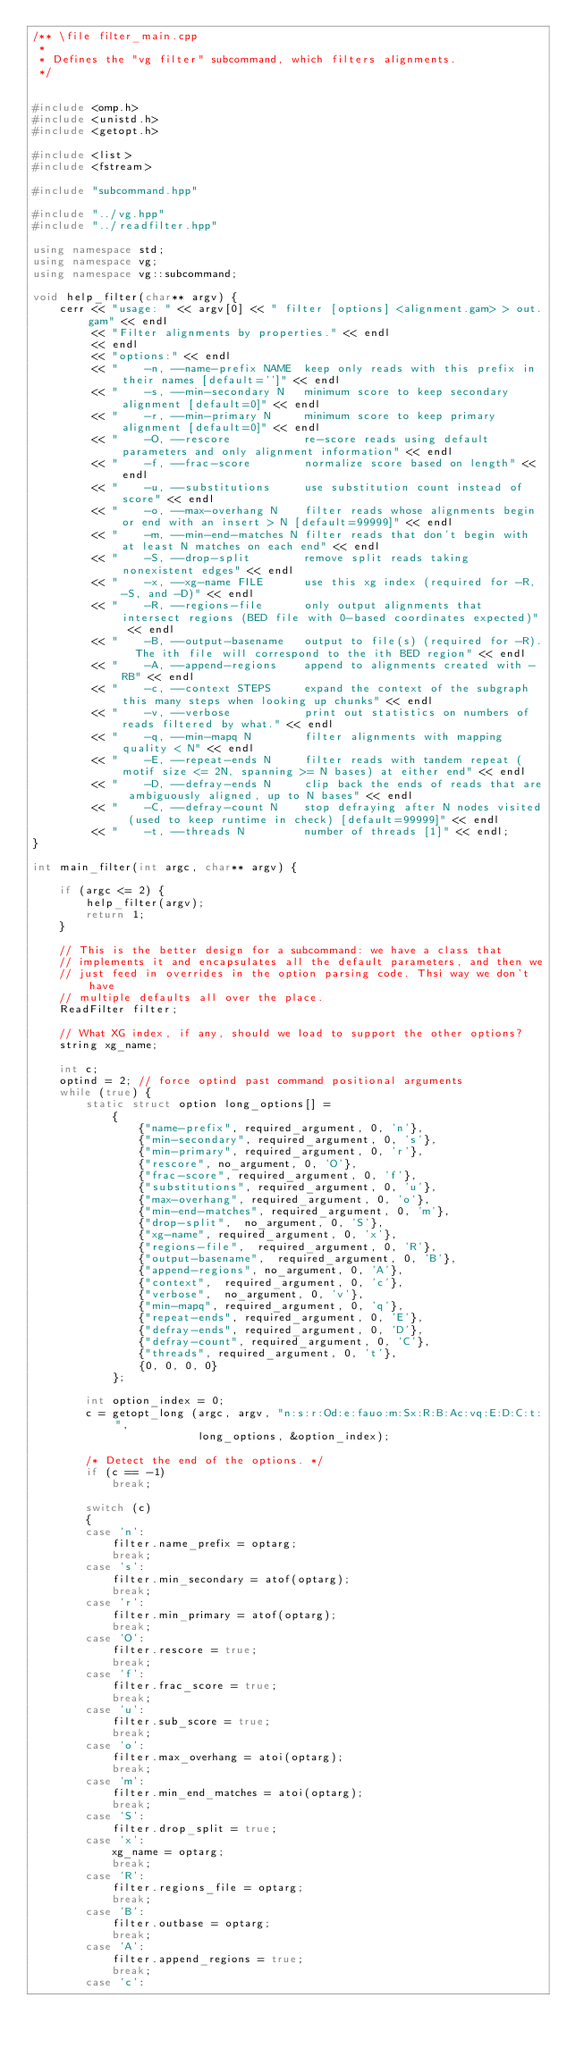Convert code to text. <code><loc_0><loc_0><loc_500><loc_500><_C++_>/** \file filter_main.cpp
 *
 * Defines the "vg filter" subcommand, which filters alignments.
 */


#include <omp.h>
#include <unistd.h>
#include <getopt.h>

#include <list>
#include <fstream>

#include "subcommand.hpp"

#include "../vg.hpp"
#include "../readfilter.hpp"

using namespace std;
using namespace vg;
using namespace vg::subcommand;

void help_filter(char** argv) {
    cerr << "usage: " << argv[0] << " filter [options] <alignment.gam> > out.gam" << endl
         << "Filter alignments by properties." << endl
         << endl
         << "options:" << endl
         << "    -n, --name-prefix NAME  keep only reads with this prefix in their names [default='']" << endl
         << "    -s, --min-secondary N   minimum score to keep secondary alignment [default=0]" << endl
         << "    -r, --min-primary N     minimum score to keep primary alignment [default=0]" << endl
         << "    -O, --rescore           re-score reads using default parameters and only alignment information" << endl
         << "    -f, --frac-score        normalize score based on length" << endl
         << "    -u, --substitutions     use substitution count instead of score" << endl
         << "    -o, --max-overhang N    filter reads whose alignments begin or end with an insert > N [default=99999]" << endl
         << "    -m, --min-end-matches N filter reads that don't begin with at least N matches on each end" << endl
         << "    -S, --drop-split        remove split reads taking nonexistent edges" << endl
         << "    -x, --xg-name FILE      use this xg index (required for -R, -S, and -D)" << endl
         << "    -R, --regions-file      only output alignments that intersect regions (BED file with 0-based coordinates expected)" << endl
         << "    -B, --output-basename   output to file(s) (required for -R).  The ith file will correspond to the ith BED region" << endl
         << "    -A, --append-regions    append to alignments created with -RB" << endl
         << "    -c, --context STEPS     expand the context of the subgraph this many steps when looking up chunks" << endl
         << "    -v, --verbose           print out statistics on numbers of reads filtered by what." << endl
         << "    -q, --min-mapq N        filter alignments with mapping quality < N" << endl
         << "    -E, --repeat-ends N     filter reads with tandem repeat (motif size <= 2N, spanning >= N bases) at either end" << endl
         << "    -D, --defray-ends N     clip back the ends of reads that are ambiguously aligned, up to N bases" << endl
         << "    -C, --defray-count N    stop defraying after N nodes visited (used to keep runtime in check) [default=99999]" << endl
         << "    -t, --threads N         number of threads [1]" << endl;
}

int main_filter(int argc, char** argv) {

    if (argc <= 2) {
        help_filter(argv);
        return 1;
    }

    // This is the better design for a subcommand: we have a class that
    // implements it and encapsulates all the default parameters, and then we
    // just feed in overrides in the option parsing code. Thsi way we don't have
    // multiple defaults all over the place.
    ReadFilter filter;

    // What XG index, if any, should we load to support the other options?
    string xg_name;

    int c;
    optind = 2; // force optind past command positional arguments
    while (true) {
        static struct option long_options[] =
            {
                {"name-prefix", required_argument, 0, 'n'},
                {"min-secondary", required_argument, 0, 's'},
                {"min-primary", required_argument, 0, 'r'},
                {"rescore", no_argument, 0, 'O'},
                {"frac-score", required_argument, 0, 'f'},
                {"substitutions", required_argument, 0, 'u'},
                {"max-overhang", required_argument, 0, 'o'},
                {"min-end-matches", required_argument, 0, 'm'},
                {"drop-split",  no_argument, 0, 'S'},
                {"xg-name", required_argument, 0, 'x'},
                {"regions-file",  required_argument, 0, 'R'},
                {"output-basename",  required_argument, 0, 'B'},
                {"append-regions", no_argument, 0, 'A'},
                {"context",  required_argument, 0, 'c'},
                {"verbose",  no_argument, 0, 'v'},
                {"min-mapq", required_argument, 0, 'q'},
                {"repeat-ends", required_argument, 0, 'E'},
                {"defray-ends", required_argument, 0, 'D'},
                {"defray-count", required_argument, 0, 'C'},
                {"threads", required_argument, 0, 't'},
                {0, 0, 0, 0}
            };

        int option_index = 0;
        c = getopt_long (argc, argv, "n:s:r:Od:e:fauo:m:Sx:R:B:Ac:vq:E:D:C:t:",
                         long_options, &option_index);

        /* Detect the end of the options. */
        if (c == -1)
            break;

        switch (c)
        {
        case 'n':
            filter.name_prefix = optarg;
            break;
        case 's':
            filter.min_secondary = atof(optarg);
            break;
        case 'r':
            filter.min_primary = atof(optarg);
            break;
        case 'O':
            filter.rescore = true;
            break;
        case 'f':
            filter.frac_score = true;
            break;
        case 'u':
            filter.sub_score = true;
            break;
        case 'o':
            filter.max_overhang = atoi(optarg);
            break;
        case 'm':
            filter.min_end_matches = atoi(optarg);
            break;            
        case 'S':
            filter.drop_split = true;
        case 'x':
            xg_name = optarg;
            break;
        case 'R':
            filter.regions_file = optarg;
            break;
        case 'B':
            filter.outbase = optarg;
            break;
        case 'A':
            filter.append_regions = true;
            break;
        case 'c':</code> 